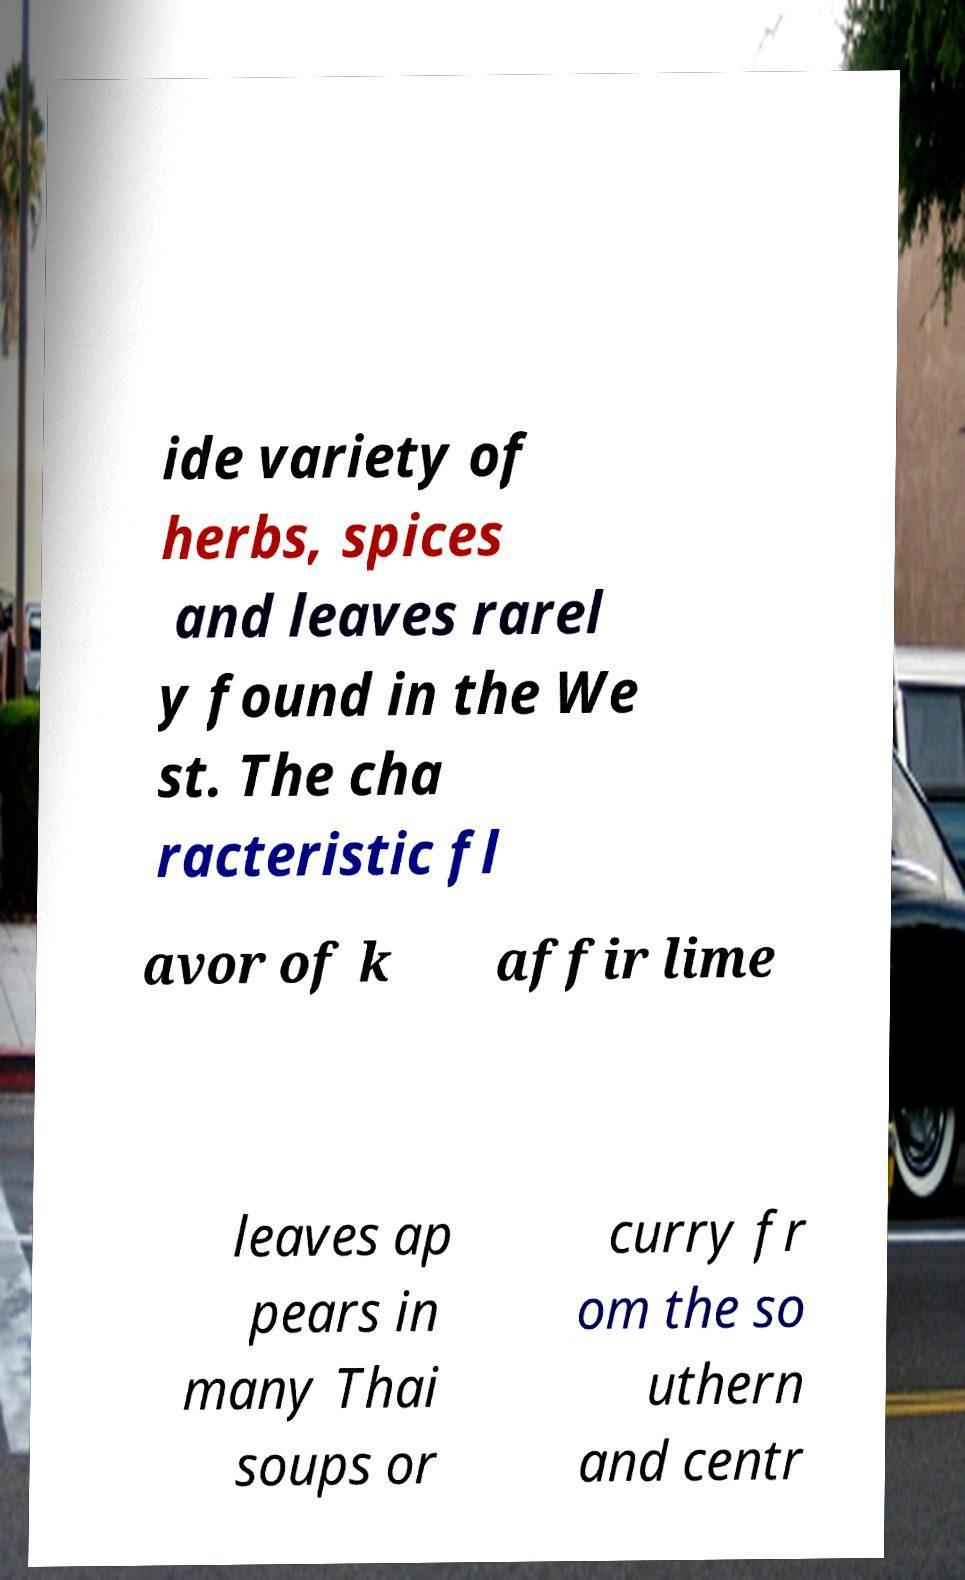I need the written content from this picture converted into text. Can you do that? ide variety of herbs, spices and leaves rarel y found in the We st. The cha racteristic fl avor of k affir lime leaves ap pears in many Thai soups or curry fr om the so uthern and centr 